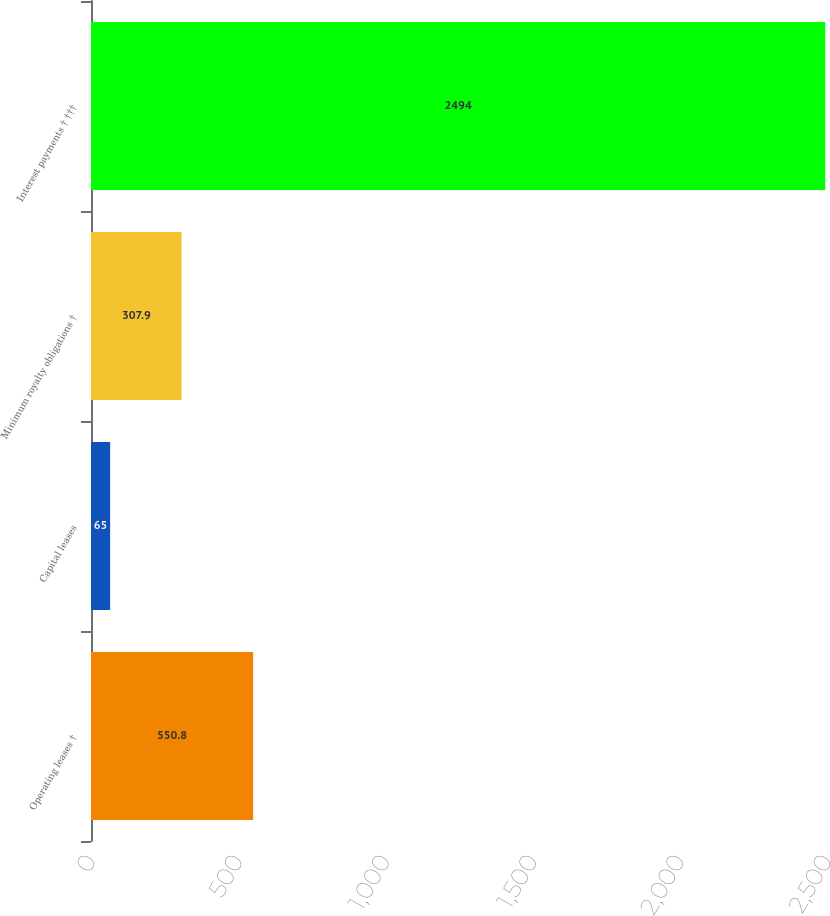Convert chart to OTSL. <chart><loc_0><loc_0><loc_500><loc_500><bar_chart><fcel>Operating leases †<fcel>Capital leases<fcel>Minimum royalty obligations †<fcel>Interest payments † †††<nl><fcel>550.8<fcel>65<fcel>307.9<fcel>2494<nl></chart> 